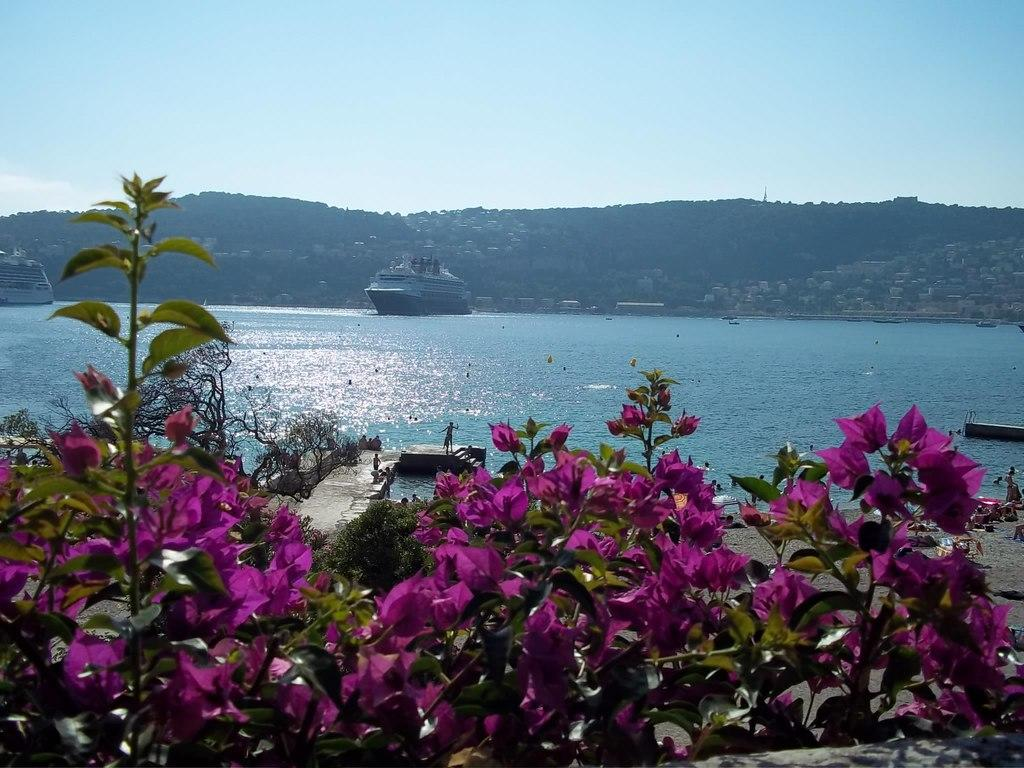What is happening in the water in the image? There are ships sailing on the water in the image. What type of vegetation can be seen in the image? Plants and flowers are visible in the image. What can be seen in the background of the image? The ground is visible in the background of the image, along with objects on the ground. What is visible in the sky in the image? The sky is visible in the image. What type of canvas is being used by the animal in the image? There is no canvas or animal present in the image. Can you hear the bell ringing in the image? There is no bell present in the image, so it cannot be heard. 